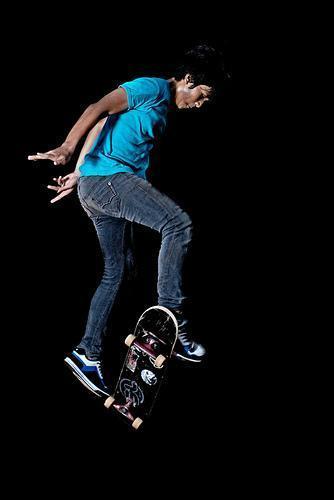How many skateboarders are pictured?
Give a very brief answer. 1. 